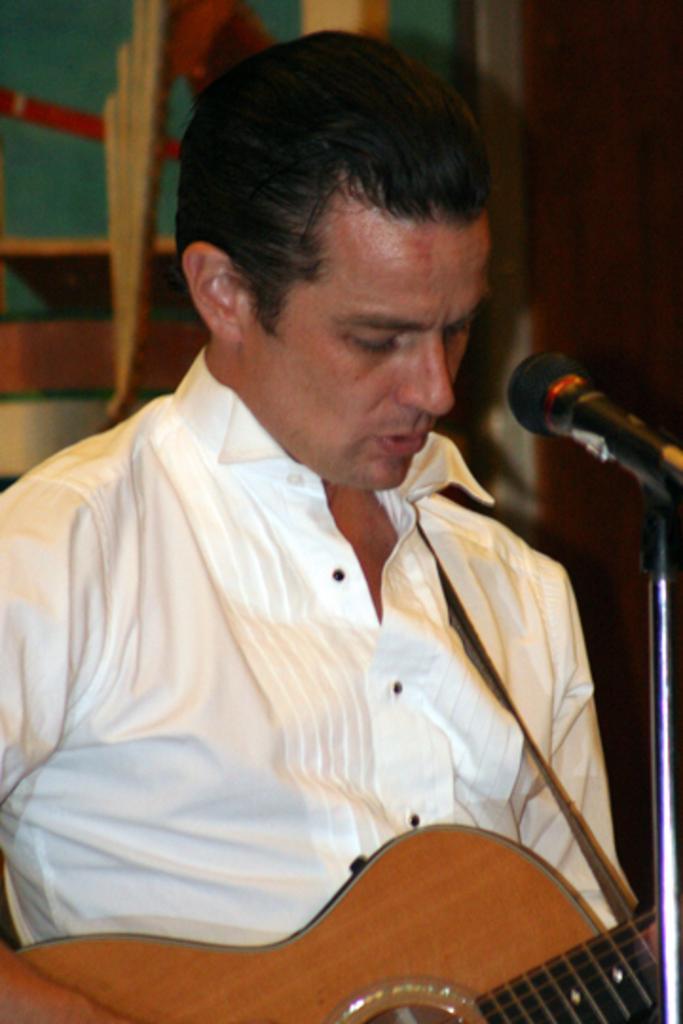Can you describe this image briefly? This picture shows a man playing a guitar in his hands, in front of a mic. 